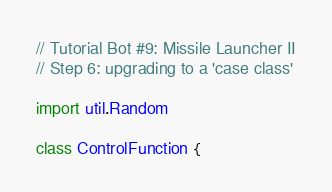<code> <loc_0><loc_0><loc_500><loc_500><_Scala_>// Tutorial Bot #9: Missile Launcher II
// Step 6: upgrading to a 'case class'

import util.Random

class ControlFunction {</code> 